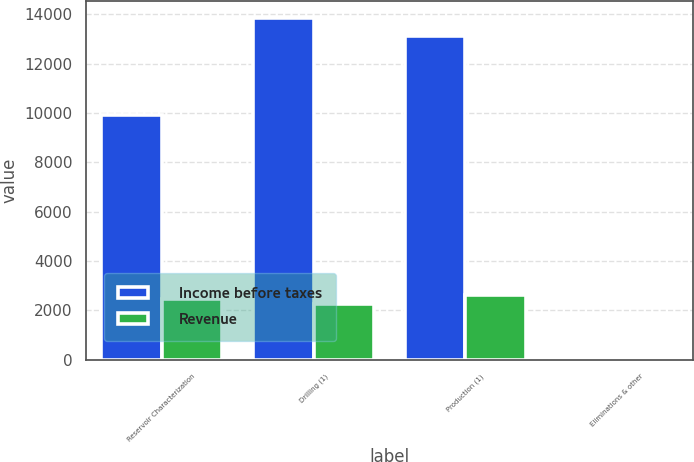Convert chart. <chart><loc_0><loc_0><loc_500><loc_500><stacked_bar_chart><ecel><fcel>Reservoir Characterization<fcel>Drilling (1)<fcel>Production (1)<fcel>Eliminations & other<nl><fcel>Income before taxes<fcel>9929<fcel>13860<fcel>13136<fcel>34<nl><fcel>Revenue<fcel>2449<fcel>2254<fcel>2637<fcel>35<nl></chart> 